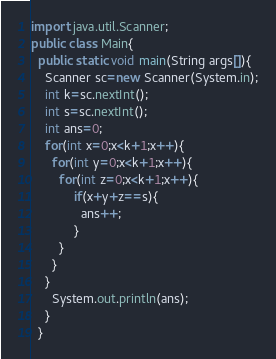Convert code to text. <code><loc_0><loc_0><loc_500><loc_500><_Java_>import java.util.Scanner;
public class Main{
  public static void main(String args[]){
    Scanner sc=new Scanner(System.in);
    int k=sc.nextInt();
    int s=sc.nextInt();
    int ans=0;
    for(int x=0;x<k+1;x++){
      for(int y=0;x<k+1;x++){
        for(int z=0;x<k+1;x++){
			if(x+y+z==s){
              ans++;
            }
        }
      }
    }
      System.out.println(ans);
    }
  }</code> 